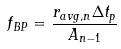<formula> <loc_0><loc_0><loc_500><loc_500>f _ { B P } = \frac { r _ { a v g , n } \Delta t _ { p } } { A _ { n - 1 } }</formula> 